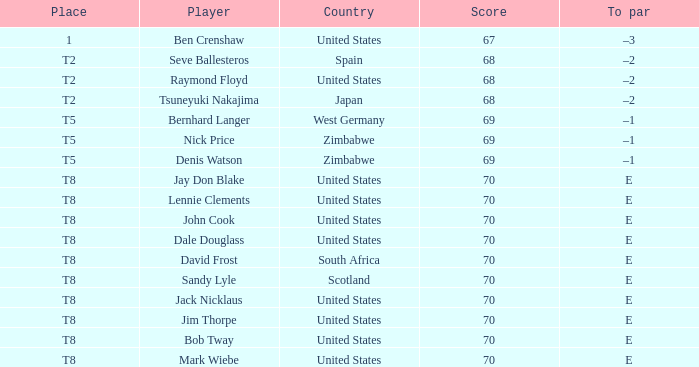What player has The United States as the country, with t2 as the place? Raymond Floyd. Parse the full table. {'header': ['Place', 'Player', 'Country', 'Score', 'To par'], 'rows': [['1', 'Ben Crenshaw', 'United States', '67', '–3'], ['T2', 'Seve Ballesteros', 'Spain', '68', '–2'], ['T2', 'Raymond Floyd', 'United States', '68', '–2'], ['T2', 'Tsuneyuki Nakajima', 'Japan', '68', '–2'], ['T5', 'Bernhard Langer', 'West Germany', '69', '–1'], ['T5', 'Nick Price', 'Zimbabwe', '69', '–1'], ['T5', 'Denis Watson', 'Zimbabwe', '69', '–1'], ['T8', 'Jay Don Blake', 'United States', '70', 'E'], ['T8', 'Lennie Clements', 'United States', '70', 'E'], ['T8', 'John Cook', 'United States', '70', 'E'], ['T8', 'Dale Douglass', 'United States', '70', 'E'], ['T8', 'David Frost', 'South Africa', '70', 'E'], ['T8', 'Sandy Lyle', 'Scotland', '70', 'E'], ['T8', 'Jack Nicklaus', 'United States', '70', 'E'], ['T8', 'Jim Thorpe', 'United States', '70', 'E'], ['T8', 'Bob Tway', 'United States', '70', 'E'], ['T8', 'Mark Wiebe', 'United States', '70', 'E']]} 